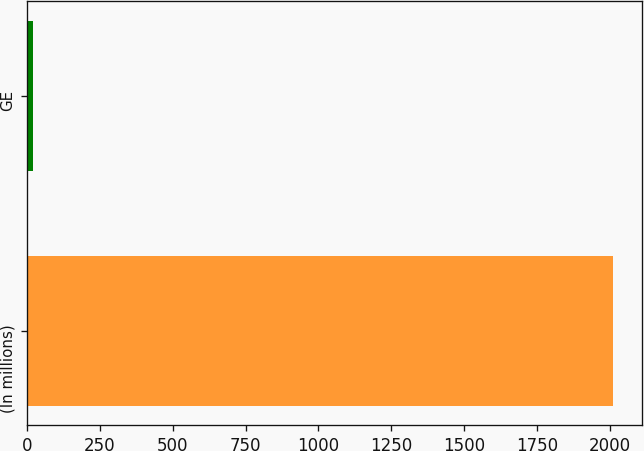<chart> <loc_0><loc_0><loc_500><loc_500><bar_chart><fcel>(In millions)<fcel>GE<nl><fcel>2011<fcel>21<nl></chart> 